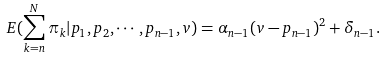<formula> <loc_0><loc_0><loc_500><loc_500>E ( \sum ^ { N } _ { k = n } \pi _ { k } | p _ { 1 } , p _ { 2 } , \cdots , p _ { n - 1 } , v ) = \alpha _ { n - 1 } ( v - p _ { n - 1 } ) ^ { 2 } + \delta _ { n - 1 } .</formula> 